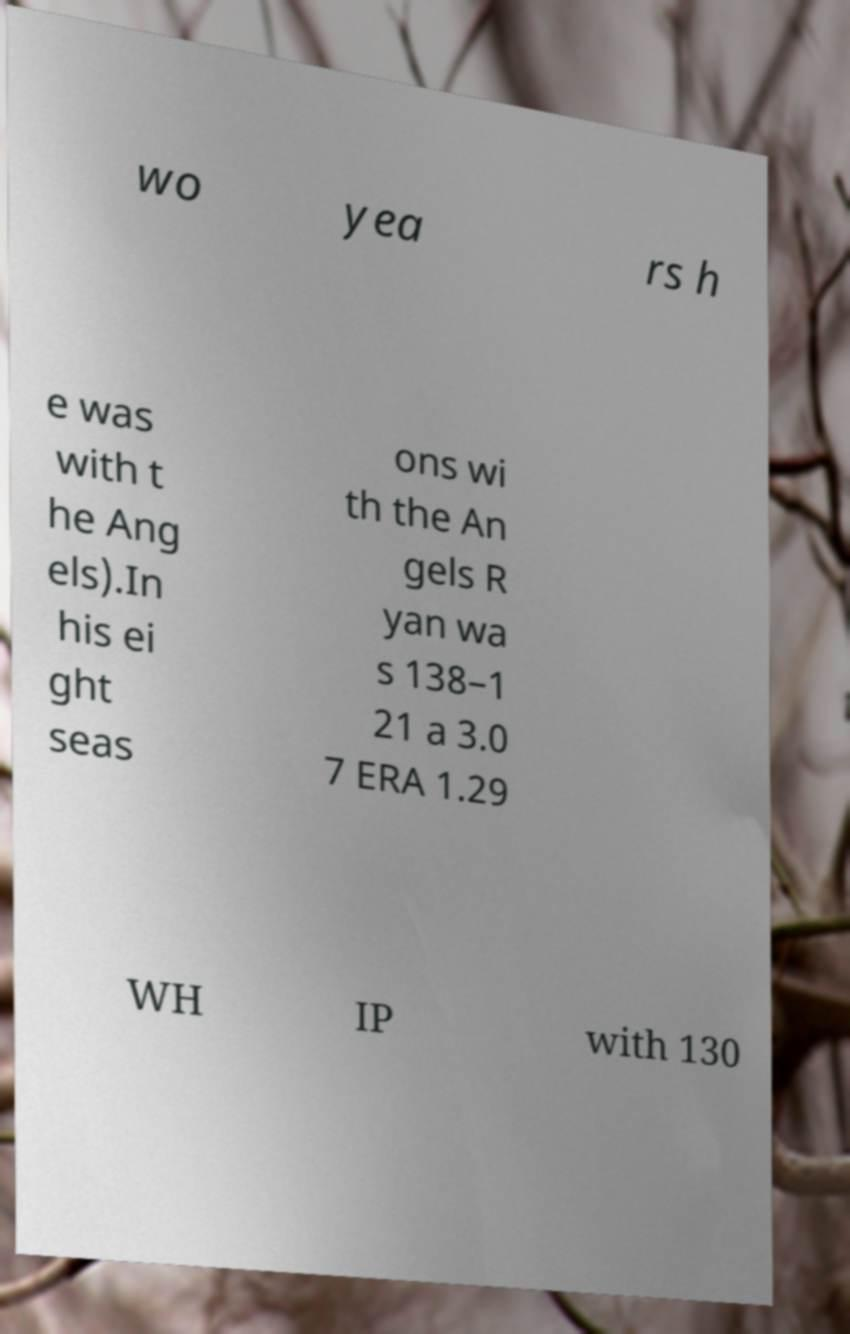Can you read and provide the text displayed in the image?This photo seems to have some interesting text. Can you extract and type it out for me? wo yea rs h e was with t he Ang els).In his ei ght seas ons wi th the An gels R yan wa s 138–1 21 a 3.0 7 ERA 1.29 WH IP with 130 